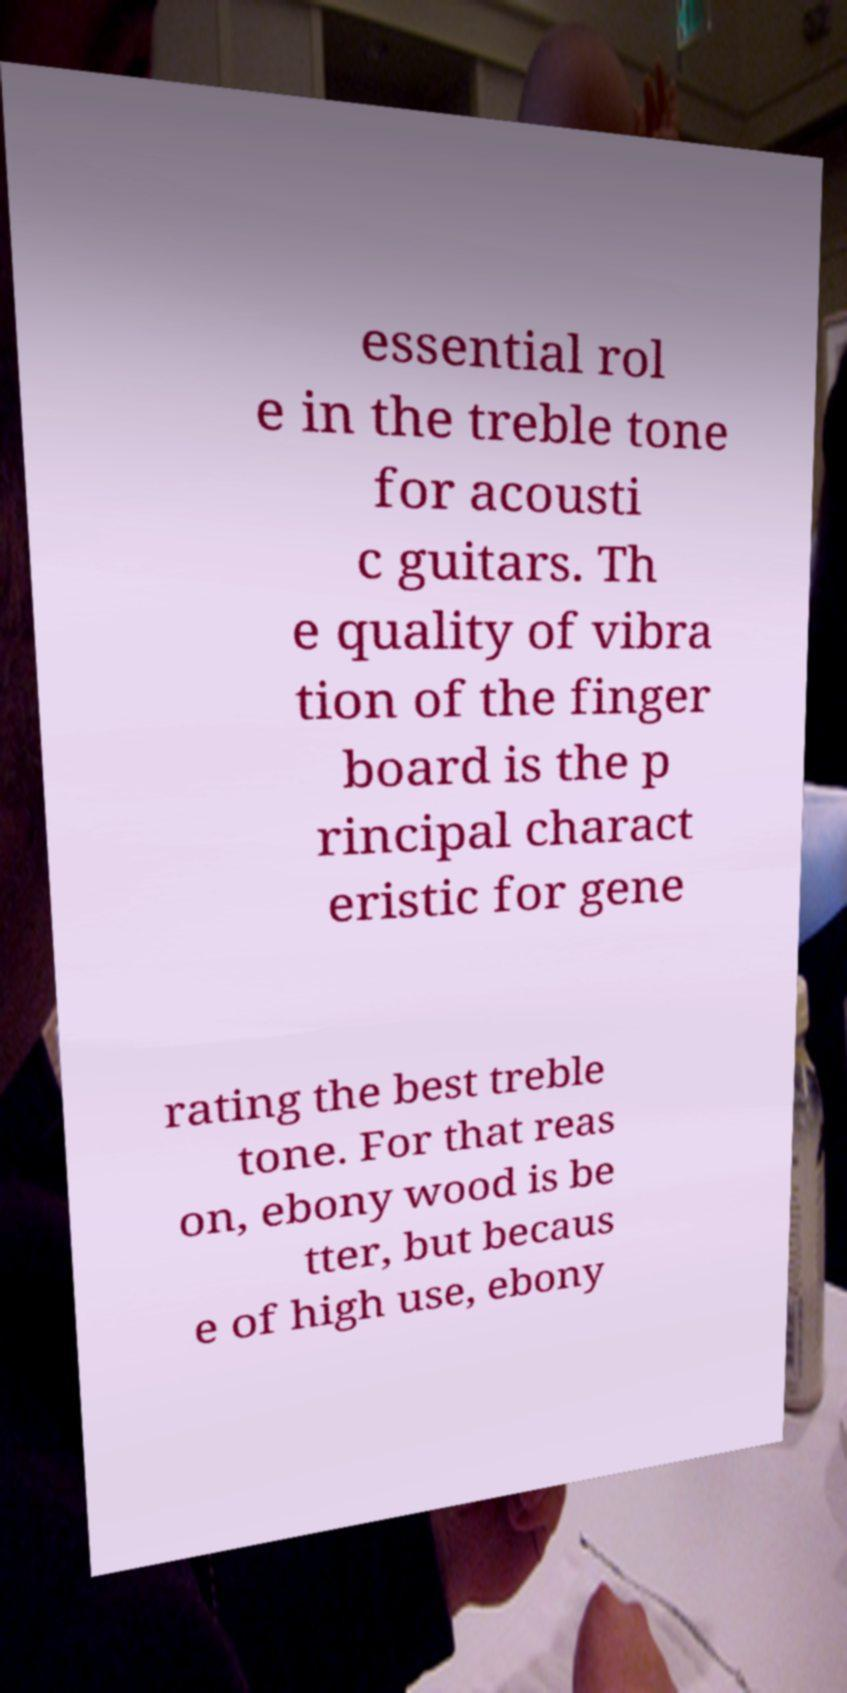Can you accurately transcribe the text from the provided image for me? essential rol e in the treble tone for acousti c guitars. Th e quality of vibra tion of the finger board is the p rincipal charact eristic for gene rating the best treble tone. For that reas on, ebony wood is be tter, but becaus e of high use, ebony 